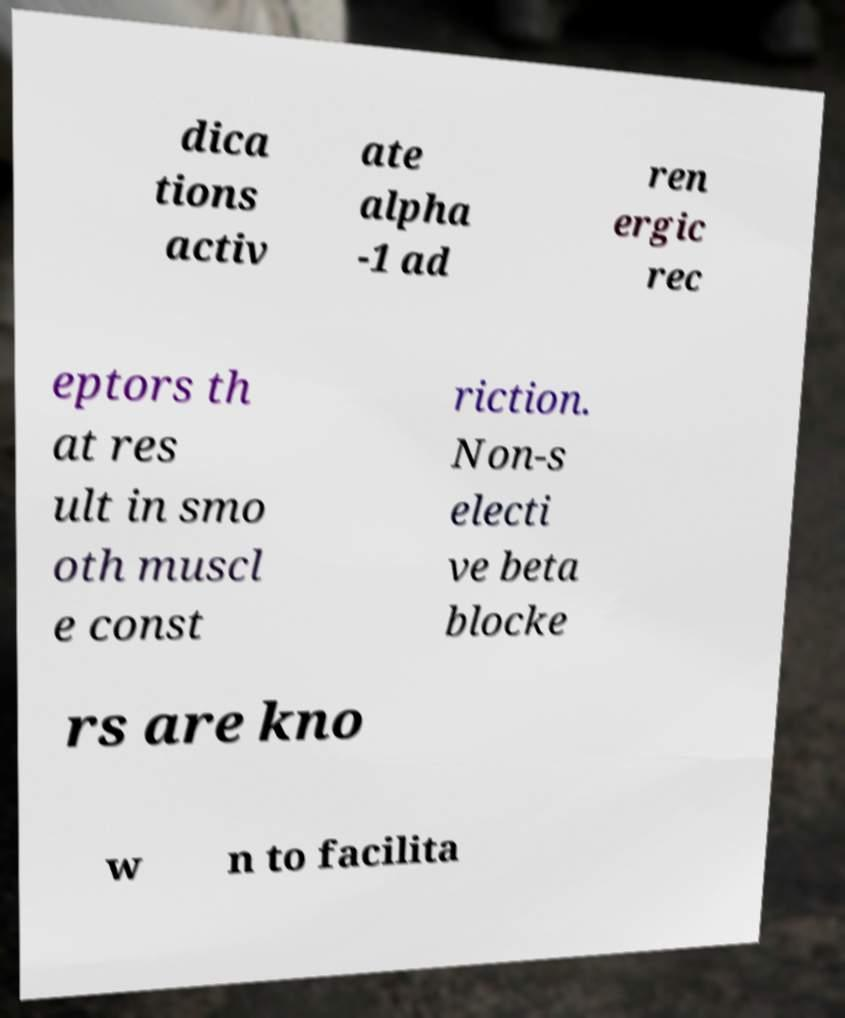Please identify and transcribe the text found in this image. dica tions activ ate alpha -1 ad ren ergic rec eptors th at res ult in smo oth muscl e const riction. Non-s electi ve beta blocke rs are kno w n to facilita 